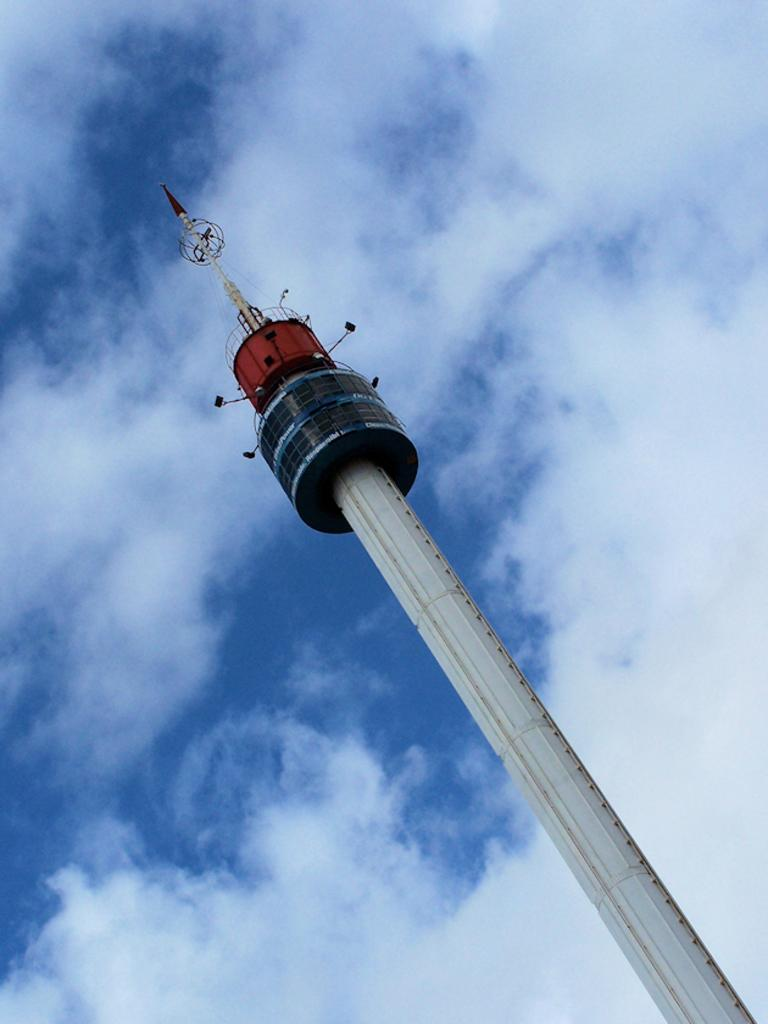What is the main structure in the image? There is a lighthouse in the image. What can be seen on the lighthouse? There are lights on the lighthouse. What other object is visible in the image? There is a grille in the image. What is visible in the background of the image? The sky is visible in the background of the image. What type of weather is suggested by the clouds in the sky? The presence of clouds in the sky suggests that it might be partly cloudy. Where is the camera located in the image? There is no camera present in the image. What type of tool is being used to rake the gravel in the image? There is no rake or gravel present in the image. 